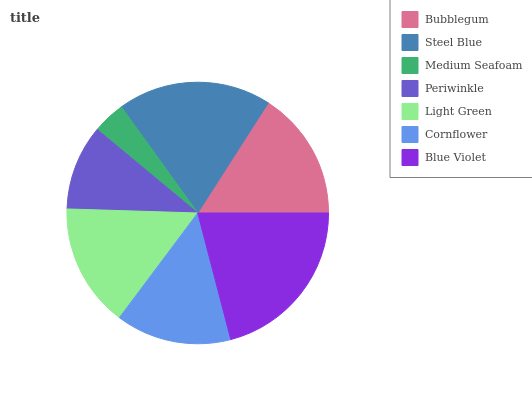Is Medium Seafoam the minimum?
Answer yes or no. Yes. Is Blue Violet the maximum?
Answer yes or no. Yes. Is Steel Blue the minimum?
Answer yes or no. No. Is Steel Blue the maximum?
Answer yes or no. No. Is Steel Blue greater than Bubblegum?
Answer yes or no. Yes. Is Bubblegum less than Steel Blue?
Answer yes or no. Yes. Is Bubblegum greater than Steel Blue?
Answer yes or no. No. Is Steel Blue less than Bubblegum?
Answer yes or no. No. Is Light Green the high median?
Answer yes or no. Yes. Is Light Green the low median?
Answer yes or no. Yes. Is Steel Blue the high median?
Answer yes or no. No. Is Bubblegum the low median?
Answer yes or no. No. 